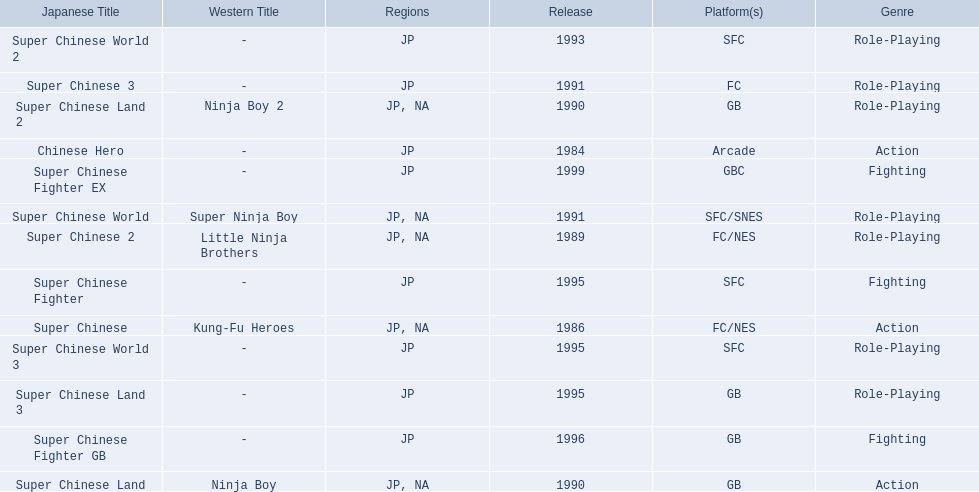What japanese titles were released in the north american (na) region? Super Chinese, Super Chinese 2, Super Chinese Land, Super Chinese Land 2, Super Chinese World. Of those, which one was released most recently? Super Chinese World. 